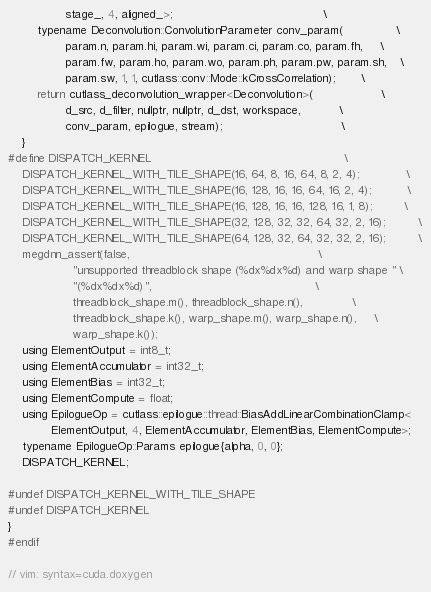<code> <loc_0><loc_0><loc_500><loc_500><_Cuda_>                stage_, 4, aligned_>;                                          \
        typename Deconvolution::ConvolutionParameter conv_param(               \
                param.n, param.hi, param.wi, param.ci, param.co, param.fh,     \
                param.fw, param.ho, param.wo, param.ph, param.pw, param.sh,    \
                param.sw, 1, 1, cutlass::conv::Mode::kCrossCorrelation);       \
        return cutlass_deconvolution_wrapper<Deconvolution>(                   \
                d_src, d_filter, nullptr, nullptr, d_dst, workspace,           \
                conv_param, epilogue, stream);                                 \
    }
#define DISPATCH_KERNEL                                                      \
    DISPATCH_KERNEL_WITH_TILE_SHAPE(16, 64, 8, 16, 64, 8, 2, 4);             \
    DISPATCH_KERNEL_WITH_TILE_SHAPE(16, 128, 16, 16, 64, 16, 2, 4);          \
    DISPATCH_KERNEL_WITH_TILE_SHAPE(16, 128, 16, 16, 128, 16, 1, 8);         \
    DISPATCH_KERNEL_WITH_TILE_SHAPE(32, 128, 32, 32, 64, 32, 2, 16);         \
    DISPATCH_KERNEL_WITH_TILE_SHAPE(64, 128, 32, 64, 32, 32, 2, 16);         \
    megdnn_assert(false,                                                     \
                  "unsupported threadblock shape (%dx%dx%d) and warp shape " \
                  "(%dx%dx%d)",                                              \
                  threadblock_shape.m(), threadblock_shape.n(),              \
                  threadblock_shape.k(), warp_shape.m(), warp_shape.n(),     \
                  warp_shape.k());
    using ElementOutput = int8_t;
    using ElementAccumulator = int32_t;
    using ElementBias = int32_t;
    using ElementCompute = float;
    using EpilogueOp = cutlass::epilogue::thread::BiasAddLinearCombinationClamp<
            ElementOutput, 4, ElementAccumulator, ElementBias, ElementCompute>;
    typename EpilogueOp::Params epilogue{alpha, 0, 0};
    DISPATCH_KERNEL;

#undef DISPATCH_KERNEL_WITH_TILE_SHAPE
#undef DISPATCH_KERNEL
}
#endif

// vim: syntax=cuda.doxygen
</code> 